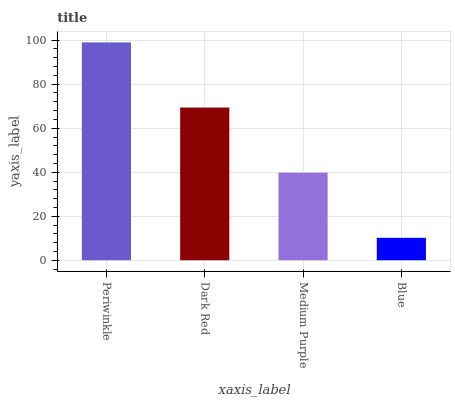Is Blue the minimum?
Answer yes or no. Yes. Is Periwinkle the maximum?
Answer yes or no. Yes. Is Dark Red the minimum?
Answer yes or no. No. Is Dark Red the maximum?
Answer yes or no. No. Is Periwinkle greater than Dark Red?
Answer yes or no. Yes. Is Dark Red less than Periwinkle?
Answer yes or no. Yes. Is Dark Red greater than Periwinkle?
Answer yes or no. No. Is Periwinkle less than Dark Red?
Answer yes or no. No. Is Dark Red the high median?
Answer yes or no. Yes. Is Medium Purple the low median?
Answer yes or no. Yes. Is Periwinkle the high median?
Answer yes or no. No. Is Dark Red the low median?
Answer yes or no. No. 